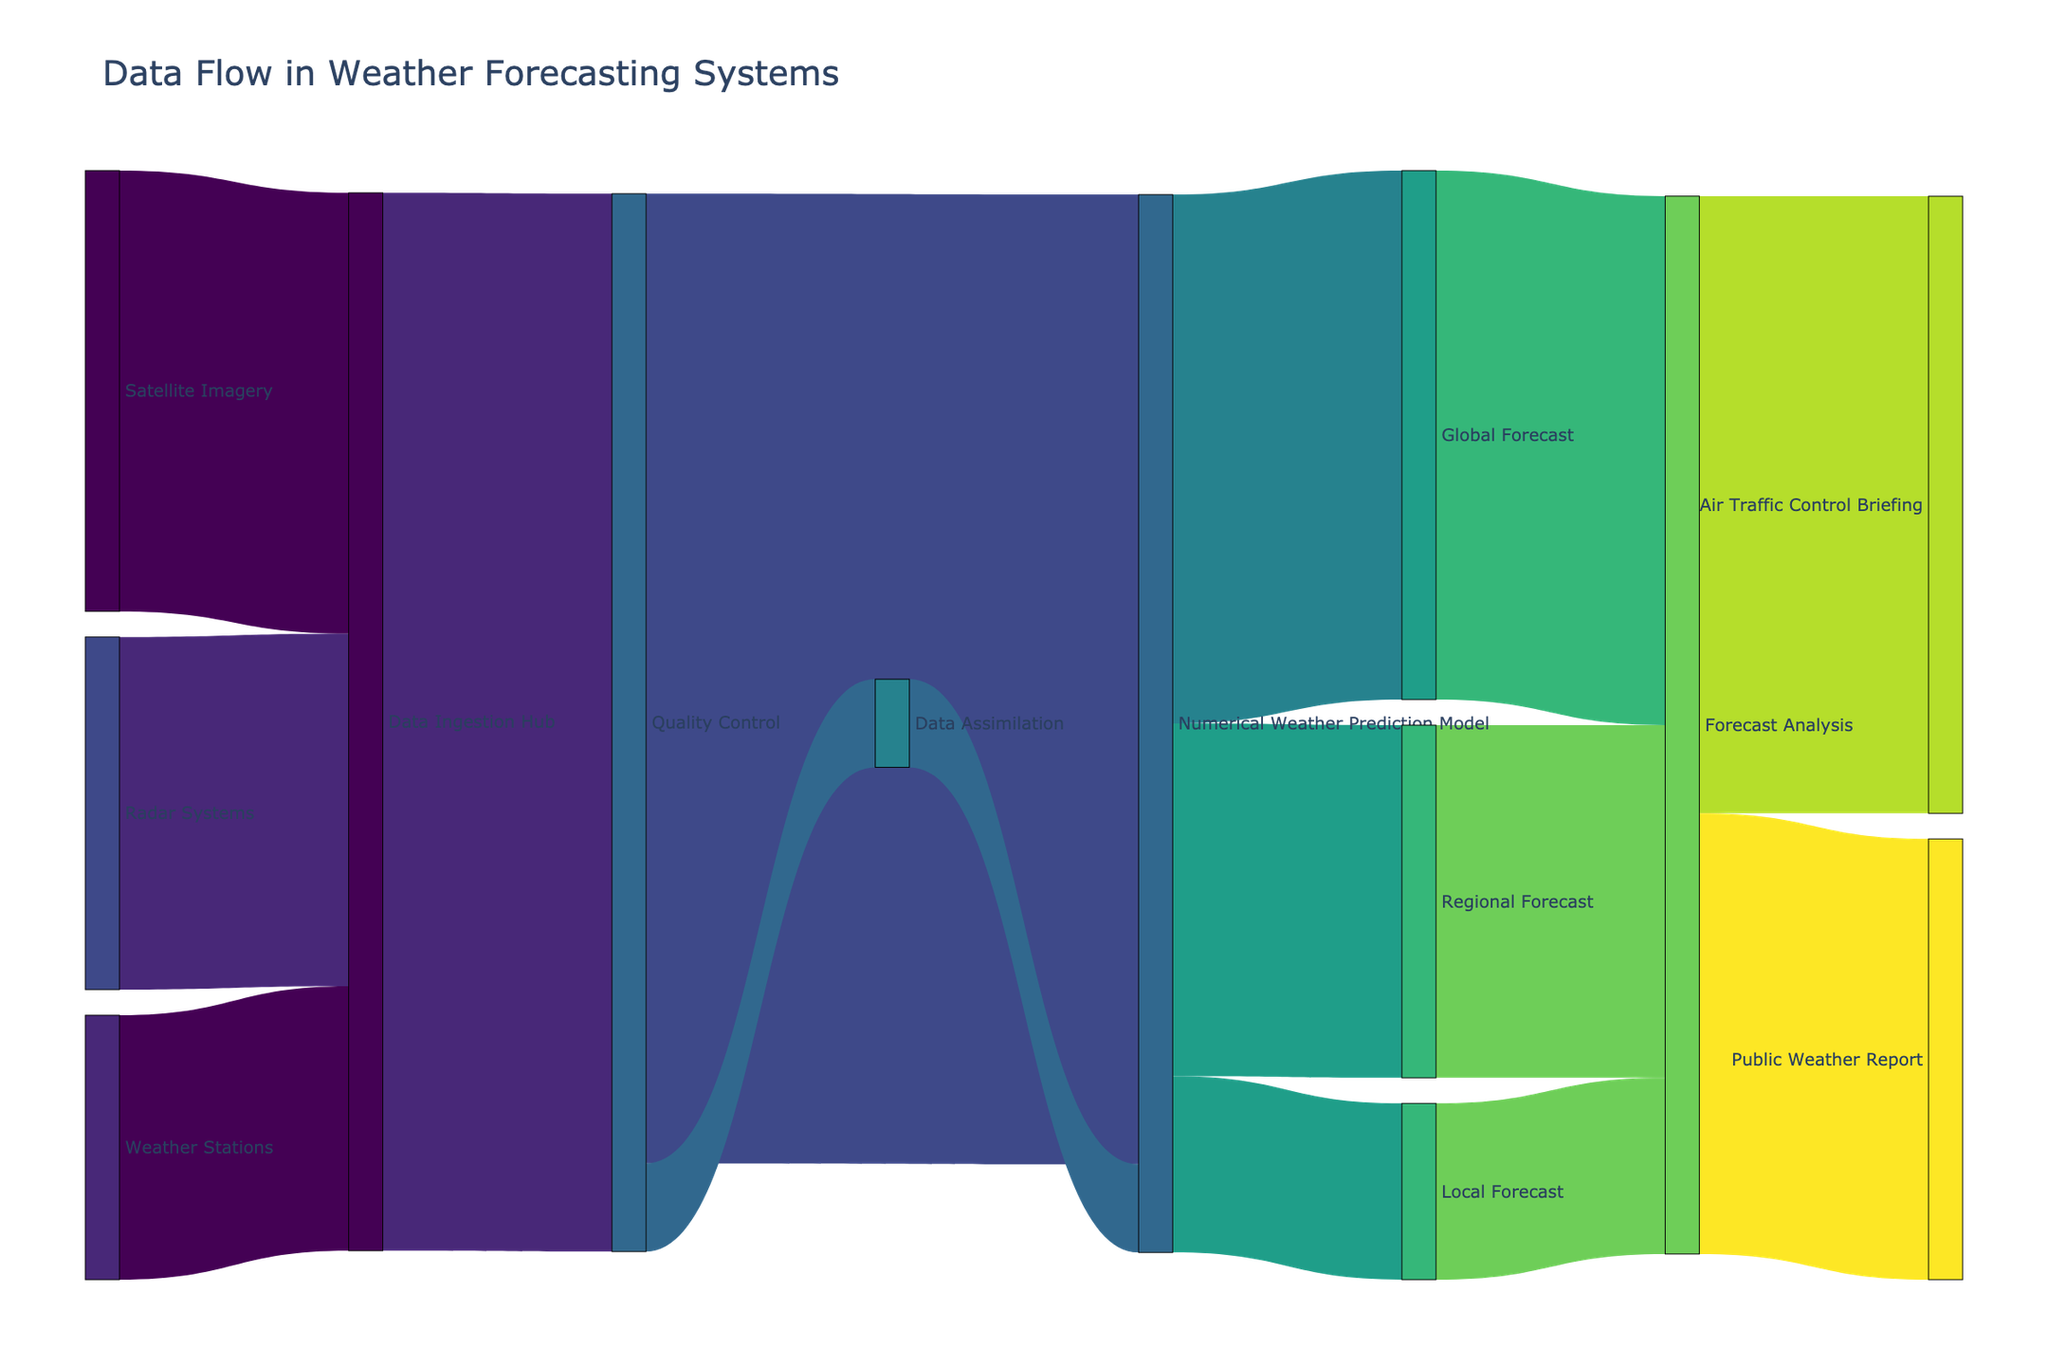what is the role of the "Quality Control" node? The "Quality Control" node connects to both the "Numerical Weather Prediction Model" and the "Data Assimilation" nodes. It ensures the integrity and accuracy of data before it is processed by these subsequent nodes.
Answer: ensures data integrity before processing which node has the highest number of incoming connections? "Quality Control" has incoming connections from "Data Ingestion Hub" and "Data Assimilation", indicating it receives initial data from these sources.
Answer: Quality Control what is the total flow of data leading to the "Forecast Analysis" node? Adding the flows from "Global Forecast," "Regional Forecast," and "Local Forecast" to "Forecast Analysis" (60 + 40 + 20), the total flow of data is 120.
Answer: 120 how many sources contribute data directly to the "Numerical Weather Prediction Model"? "Numerical Weather Prediction Model" receives direct data flow from two sources: "Quality Control" and "Data Assimilation".
Answer: two which node contributes the maximum data to "Quality Control"? The "Data Ingestion Hub" contributes the maximum data (120 units) to "Quality Control".
Answer: Data Ingestion Hub how does the data flow from "Satellite Imagery" reach "Air Traffic Control Briefing"? Data from "Satellite Imagery" flows to "Data Ingestion Hub", then to "Quality Control", "Numerical Weather Prediction Model", "Forecast Analysis", and finally to "Air Traffic Control Briefing".
Answer: Satellite Imagery -> Data Ingestion Hub -> Quality Control -> Numerical Weather Prediction Model -> Forecast Analysis -> Air Traffic Control Briefing what percentage of data from the "Numerical Weather Prediction Model" is used for "Global Forecast"? "Global Forecast" receives 60 units out of 120 from "Numerical Weather Prediction Model" which is 50% of the total flow (60 / 120 * 100).
Answer: 50% which forecast (Global, Regional, Local) has the least contribution to "Forecast Analysis"? The "Local Forecast" contributes the least data to "Forecast Analysis" with a flow of 20 units compared to 60 units from "Global Forecast" and 40 units from "Regional Forecast".
Answer: Local Forecast what can you infer about the relationship between "Forecast Analysis" and "Air Traffic Control Briefing"? "Forecast Analysis" provides 70 units of data to "Air Traffic Control Briefing", indicating that a significant portion of analyzed forecasts informs air traffic control decisions.
Answer: informs air traffic control decisions if data flow from "Weather Stations" is reduced by 50%, how will this impact the data flow to "Quality Control"? If data from "Weather Stations" is reduced from 30 to 15, the "Data Ingestion Hub" will receive 115 instead of 120 units, but the flow to "Quality Control" will still remain the same at 120 as it integrates data from multiple sources.
Answer: no impact 